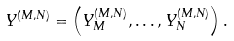<formula> <loc_0><loc_0><loc_500><loc_500>Y ^ { ( M , N ) } = \left ( Y _ { M } ^ { ( M , N ) } , \dots , Y _ { N } ^ { ( M , N ) } \right ) .</formula> 